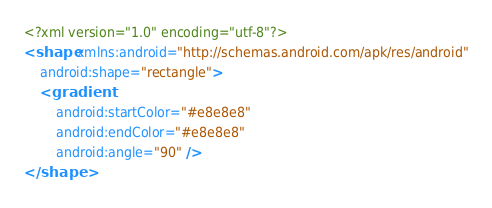<code> <loc_0><loc_0><loc_500><loc_500><_XML_><?xml version="1.0" encoding="utf-8"?>
<shape xmlns:android="http://schemas.android.com/apk/res/android"
    android:shape="rectangle">
    <gradient
        android:startColor="#e8e8e8"
        android:endColor="#e8e8e8"
        android:angle="90" />
</shape></code> 